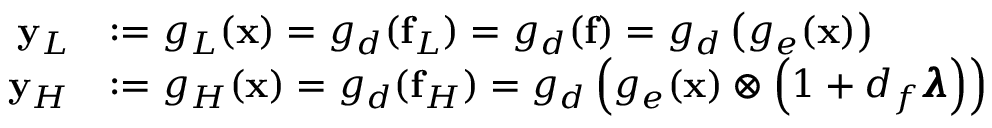<formula> <loc_0><loc_0><loc_500><loc_500>\begin{array} { r l } { y _ { L } } & { \colon = g _ { L } ( x ) = g _ { d } ( f _ { L } ) = g _ { d } ( f ) = g _ { d } \left ( g _ { e } ( x ) \right ) } \\ { y _ { H } } & { \colon = g _ { H } ( x ) = g _ { d } ( f _ { H } ) = g _ { d } \left ( g _ { e } ( x ) \otimes \left ( 1 + d _ { f } \pm b { \lambda } \right ) \right ) } \end{array}</formula> 